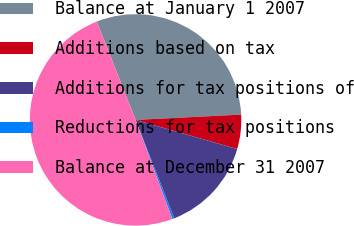<chart> <loc_0><loc_0><loc_500><loc_500><pie_chart><fcel>Balance at January 1 2007<fcel>Additions based on tax<fcel>Additions for tax positions of<fcel>Reductions for tax positions<fcel>Balance at December 31 2007<nl><fcel>30.18%<fcel>5.24%<fcel>14.59%<fcel>0.3%<fcel>49.69%<nl></chart> 